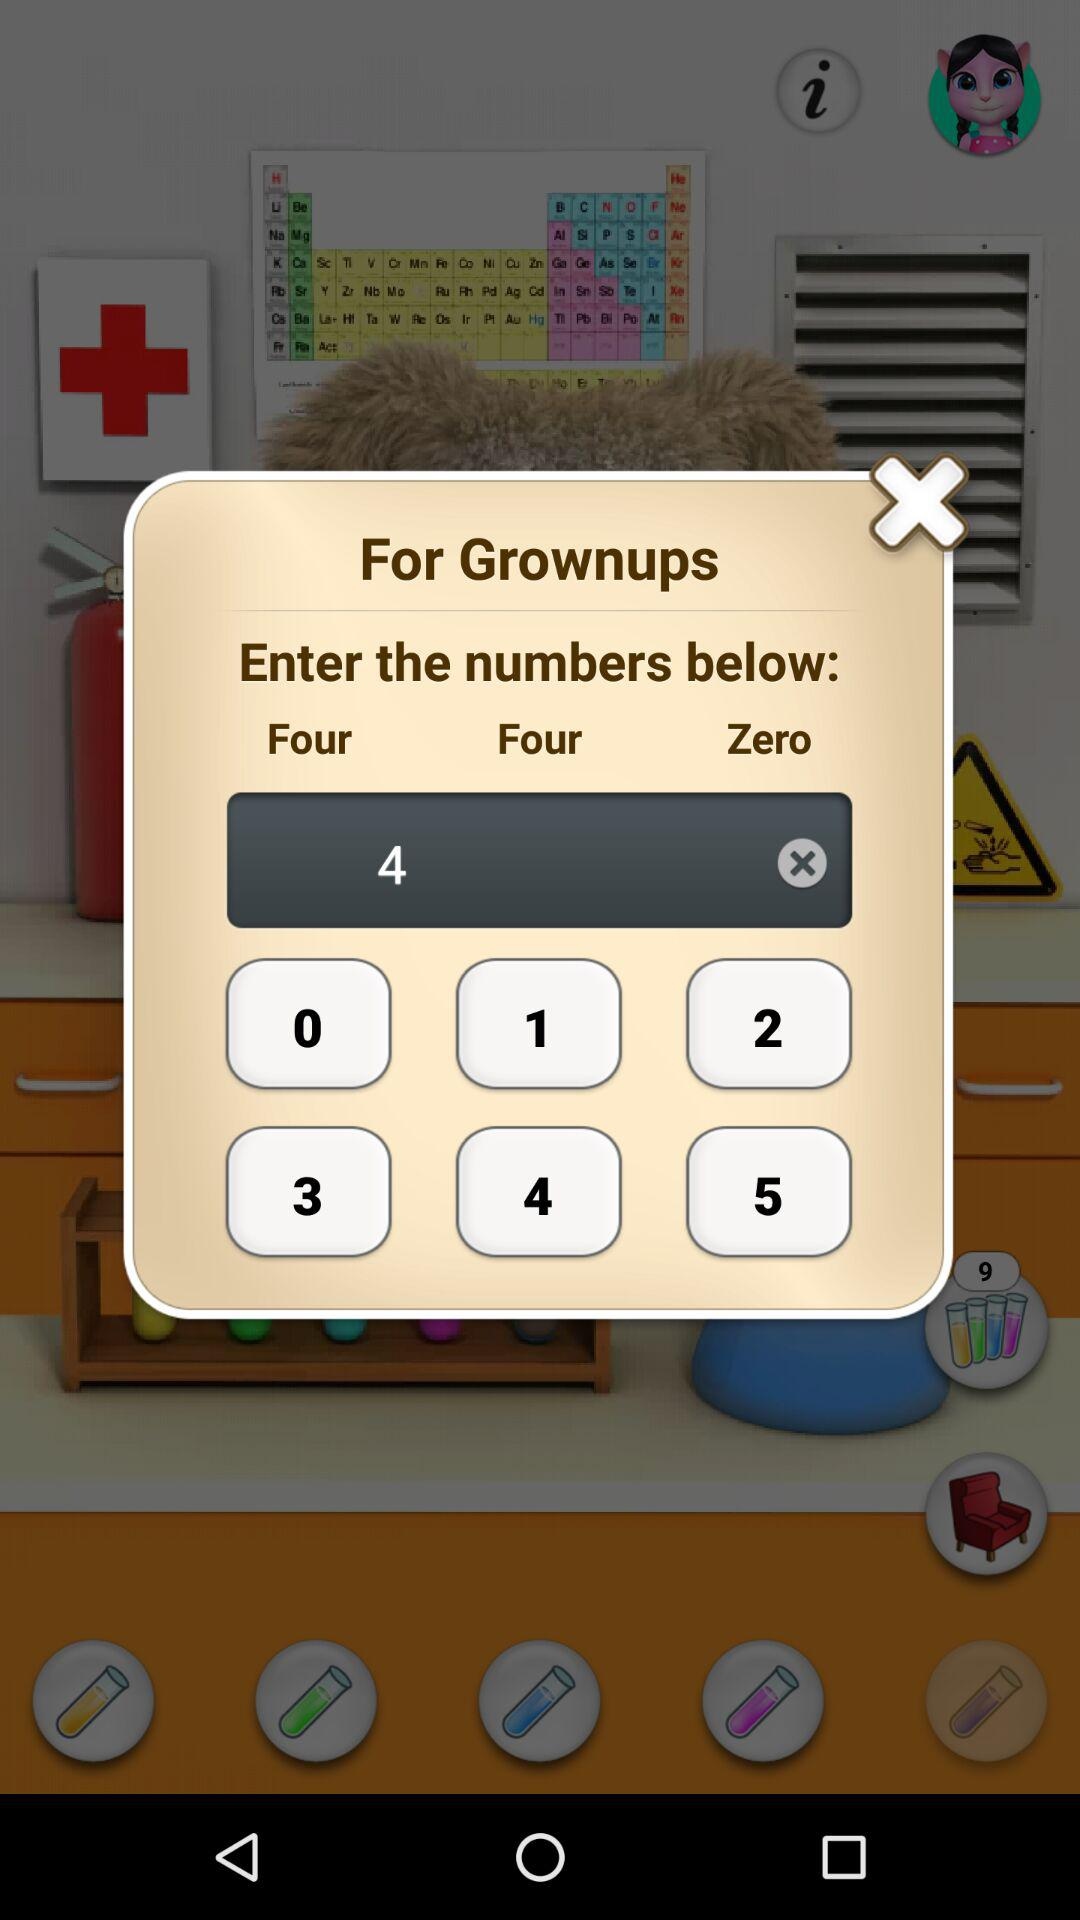What number is entered? The entered number is 4. 